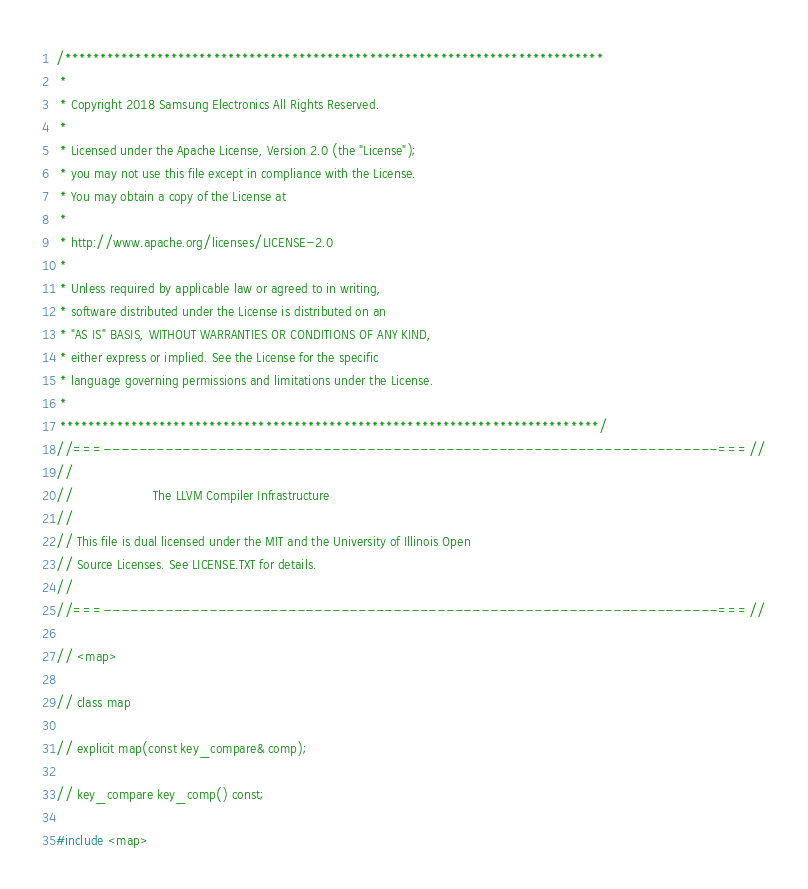<code> <loc_0><loc_0><loc_500><loc_500><_C++_>/****************************************************************************
 *
 * Copyright 2018 Samsung Electronics All Rights Reserved.
 *
 * Licensed under the Apache License, Version 2.0 (the "License");
 * you may not use this file except in compliance with the License.
 * You may obtain a copy of the License at
 *
 * http://www.apache.org/licenses/LICENSE-2.0
 *
 * Unless required by applicable law or agreed to in writing,
 * software distributed under the License is distributed on an
 * "AS IS" BASIS, WITHOUT WARRANTIES OR CONDITIONS OF ANY KIND,
 * either express or implied. See the License for the specific
 * language governing permissions and limitations under the License.
 *
 ****************************************************************************/
//===----------------------------------------------------------------------===//
//
//                     The LLVM Compiler Infrastructure
//
// This file is dual licensed under the MIT and the University of Illinois Open
// Source Licenses. See LICENSE.TXT for details.
//
//===----------------------------------------------------------------------===//

// <map>

// class map

// explicit map(const key_compare& comp);

// key_compare key_comp() const;

#include <map></code> 